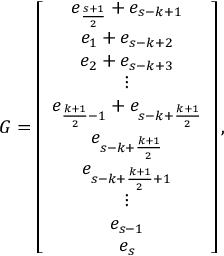<formula> <loc_0><loc_0><loc_500><loc_500>G = \left [ \begin{array} { c } { e _ { \frac { s + 1 } { 2 } } + e _ { s - k + 1 } } \\ { e _ { 1 } + e _ { s - k + 2 } } \\ { e _ { 2 } + e _ { s - k + 3 } } \\ { \vdots } \\ { e _ { \frac { k + 1 } { 2 } - 1 } + e _ { s - k + \frac { k + 1 } { 2 } } } \\ { e _ { s - k + \frac { k + 1 } { 2 } } } \\ { e _ { s - k + \frac { k + 1 } { 2 } + 1 } } \\ { \vdots } \\ { e _ { s - 1 } } \\ { e _ { s } } \end{array} \right ] ,</formula> 